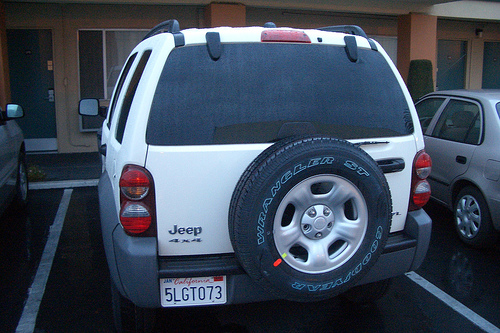<image>
Is there a tire under the window? Yes. The tire is positioned underneath the window, with the window above it in the vertical space. 